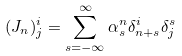Convert formula to latex. <formula><loc_0><loc_0><loc_500><loc_500>( J _ { n } ) _ { j } ^ { i } = \sum _ { s = - \infty } ^ { \infty } \alpha _ { s } ^ { n } \delta _ { n + s } ^ { i } \delta _ { j } ^ { s }</formula> 